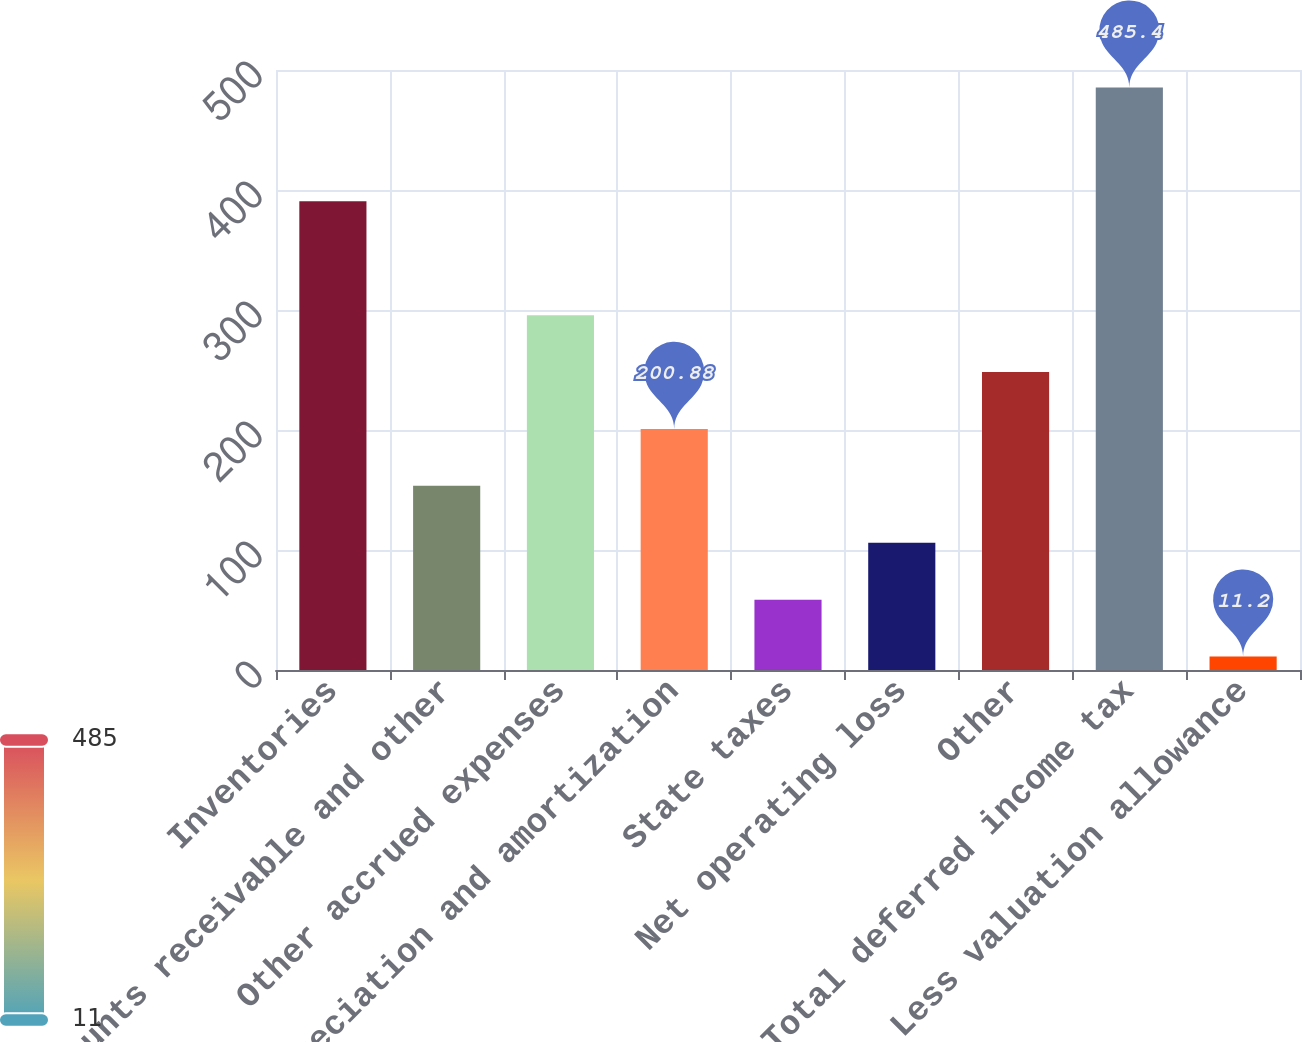Convert chart. <chart><loc_0><loc_0><loc_500><loc_500><bar_chart><fcel>Inventories<fcel>Accounts receivable and other<fcel>Other accrued expenses<fcel>Depreciation and amortization<fcel>State taxes<fcel>Net operating loss<fcel>Other<fcel>Total deferred income tax<fcel>Less valuation allowance<nl><fcel>390.56<fcel>153.46<fcel>295.72<fcel>200.88<fcel>58.62<fcel>106.04<fcel>248.3<fcel>485.4<fcel>11.2<nl></chart> 